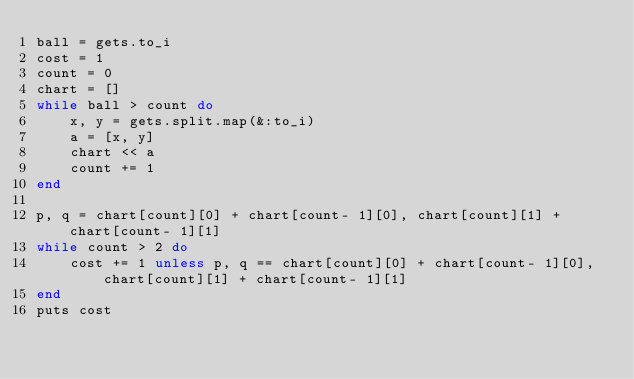<code> <loc_0><loc_0><loc_500><loc_500><_Ruby_>ball = gets.to_i
cost = 1
count = 0
chart = []
while ball > count do
    x, y = gets.split.map(&:to_i)
    a = [x, y]
    chart << a
    count += 1
end

p, q = chart[count][0] + chart[count- 1][0], chart[count][1] + chart[count- 1][1]
while count > 2 do
    cost += 1 unless p, q == chart[count][0] + chart[count- 1][0], chart[count][1] + chart[count- 1][1]
end
puts cost</code> 